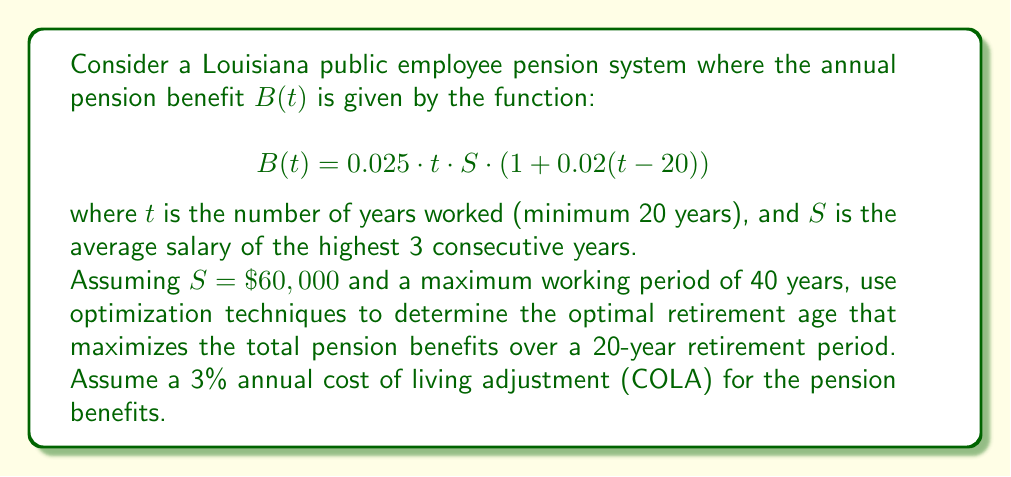Help me with this question. To solve this problem, we'll follow these steps:

1) First, we need to express the total pension benefits over the 20-year retirement period as a function of $t$. Let's call this function $P(t)$.

2) The pension benefit in the first year of retirement is $B(t)$. In subsequent years, it increases by 3% annually due to COLA.

3) The sum of this geometric series over 20 years is:

   $$P(t) = B(t) \cdot \frac{1 - 1.03^{20}}{1 - 1.03} = B(t) \cdot 26.870$$

4) Substituting the given function for $B(t)$:

   $$P(t) = 0.025 \cdot t \cdot 60000 \cdot (1 + 0.02(t-20)) \cdot 26.870$$

5) Simplifying:

   $$P(t) = 40305 \cdot t \cdot (1 + 0.02(t-20))$$

6) To find the maximum, we differentiate $P(t)$ with respect to $t$ and set it to zero:

   $$\frac{dP}{dt} = 40305 \cdot (1 + 0.02(t-20)) + 40305 \cdot t \cdot 0.02 = 0$$

7) Simplifying:

   $$1 + 0.02(t-20) + 0.02t = 0$$
   $$1 + 0.02t - 0.4 + 0.02t = 0$$
   $$0.6 + 0.04t = 0$$
   $$0.04t = -0.6$$
   $$t = -15$$

8) Since $t = -15$ is outside our domain (20 ≤ t ≤ 40), the maximum must occur at one of the endpoints.

9) Evaluating $P(t)$ at $t = 20$ and $t = 40$:

   $P(20) = 40305 \cdot 20 \cdot 1 = 806,100$
   $P(40) = 40305 \cdot 40 \cdot 1.4 = 2,257,080$

10) The maximum occurs at $t = 40$, which corresponds to retiring after 40 years of service.

11) Given that the employee must work at least 20 years, and assuming they start working at age 25, the optimal retirement age is 65.
Answer: 65 years old 